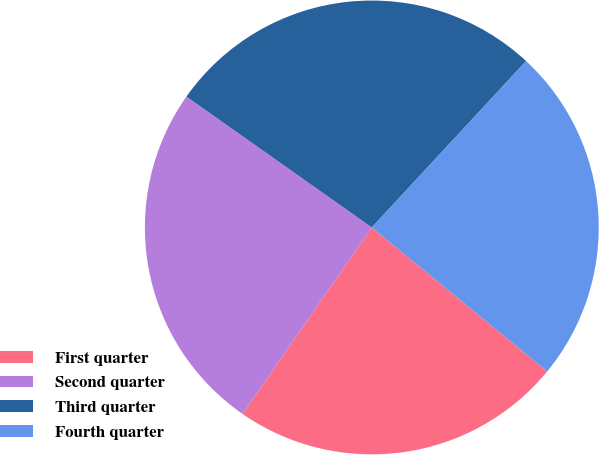<chart> <loc_0><loc_0><loc_500><loc_500><pie_chart><fcel>First quarter<fcel>Second quarter<fcel>Third quarter<fcel>Fourth quarter<nl><fcel>23.7%<fcel>25.14%<fcel>27.12%<fcel>24.04%<nl></chart> 